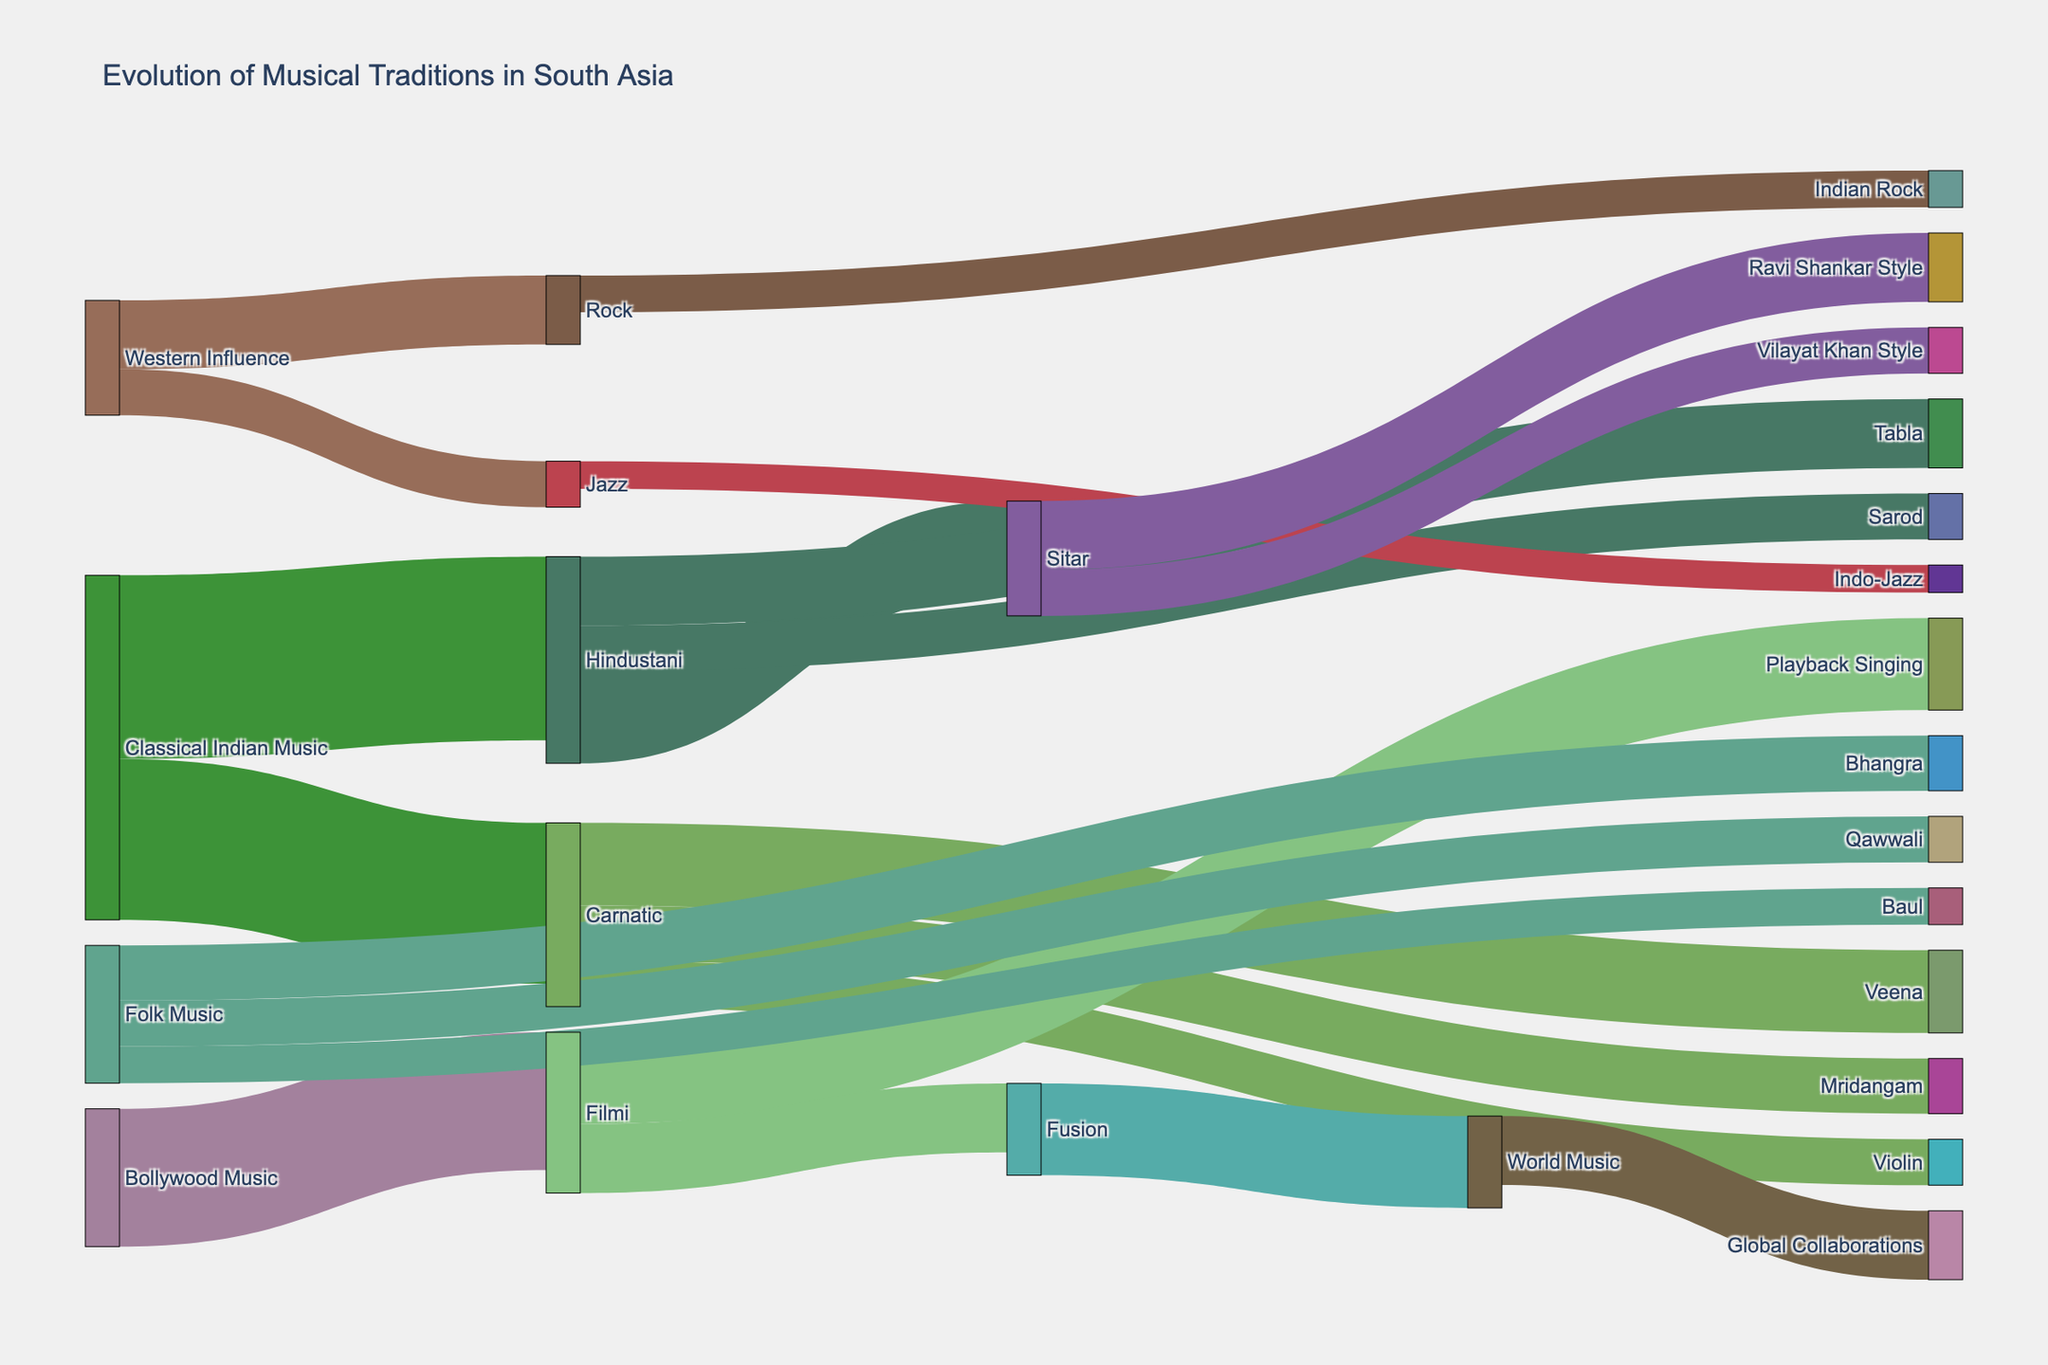What is the title of the Sankey Diagram? The title is prominently displayed at the top of the diagram. It provides context for what the diagram is showing.
Answer: Evolution of Musical Traditions in South Asia Which musical tradition has the largest connection to "Hindustani"? By observing the Sankey flows, the thickness of the connections can be compared to see which one is largest.
Answer: Sitar How many musical genres are influenced by "Western Influence"? Count the number of connections that originate from "Western Influence".
Answer: Two (Rock and Jazz) Which musical instrument has more branches under "Hindustani", Sitar or Tabla? Compare the number of connections flowing out from "Sitar" and "Tabla" under "Hindustani".
Answer: Sitar What is the combined value for the connections from "Folk Music"? Sum the values of all connections flowing out from "Folk Music" to other genres. 12 (Bhangra) + 10 (Qawwali) + 8 (Baul)
Answer: 30 What are the two primary sub-genres of "Filmi"? Look at the direct connections flowing out from "Filmi".
Answer: Playback Singing and Fusion How many branches flow out from "Carnatic"? Count the individual connections originating from "Carnatic".
Answer: Three (Veena, Mridangam, Violin) Which branch reflects the influence of "Sitar" most prominently in the Sankey Diagram? Determine the connection with the highest value flowing directly out from "Sitar".
Answer: Ravi Shankar Style How many connections flow into "Global Collaborations"? Count the number of connections directed towards "Global Collaborations".
Answer: One Which tradition has the greater representation in the diagram, "Hindustani" or "Carnatic"? Add up the values of all connections flowing out from "Hindustani" and "Carnatic" and compare them. Hindustani: 20 (Sitar) + 15 (Tabla) + 10 (Sarod) = 45
Carnatic: 18 (Veena) + 12 (Mridangam) + 10 (Violin) = 40
Answer: Hindustani 